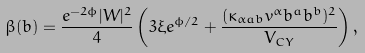<formula> <loc_0><loc_0><loc_500><loc_500>\beta ( b ) = \frac { e ^ { - 2 \phi } | W | ^ { 2 } } { 4 } \left ( 3 \xi e ^ { \phi / 2 } + \frac { ( \kappa _ { \alpha a b } v ^ { \alpha } b ^ { a } b ^ { b } ) ^ { 2 } } { V _ { C Y } } \right ) ,</formula> 